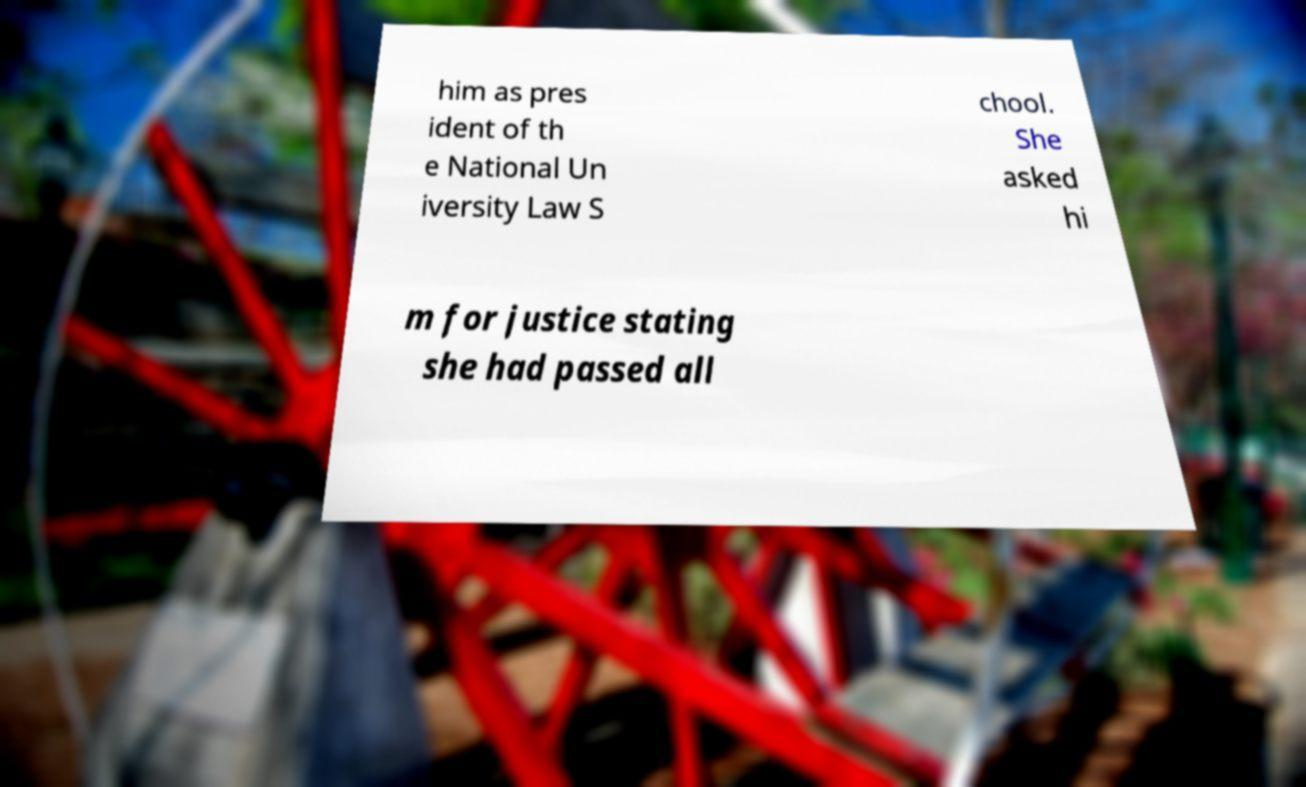For documentation purposes, I need the text within this image transcribed. Could you provide that? him as pres ident of th e National Un iversity Law S chool. She asked hi m for justice stating she had passed all 